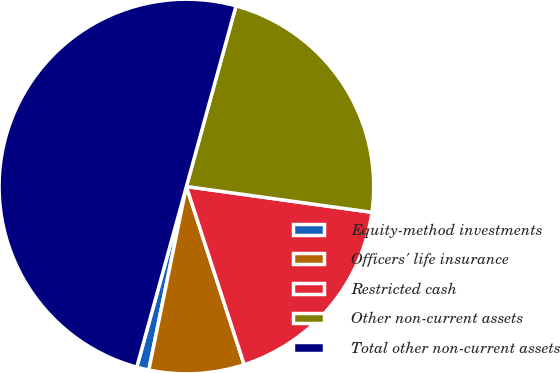Convert chart to OTSL. <chart><loc_0><loc_0><loc_500><loc_500><pie_chart><fcel>Equity-method investments<fcel>Officers' life insurance<fcel>Restricted cash<fcel>Other non-current assets<fcel>Total other non-current assets<nl><fcel>1.05%<fcel>8.21%<fcel>17.81%<fcel>22.93%<fcel>50.0%<nl></chart> 